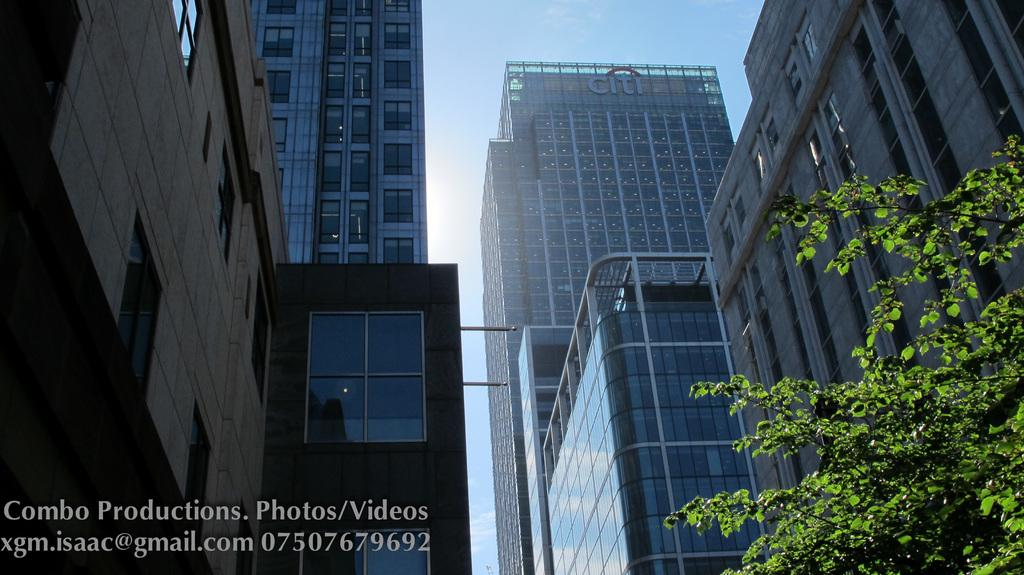What can be seen in the image? There are many buildings in the image. Where is the tree located in the image? The tree is on the right side of the image. What is visible in the background of the image? The sky is visible in the background of the image. How does the tree attract the attention of the buildings in the image? The tree does not attract the attention of the buildings in the image; it is simply located on the right side of the image. 